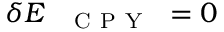<formula> <loc_0><loc_0><loc_500><loc_500>\delta E _ { { C P Y } } = 0</formula> 